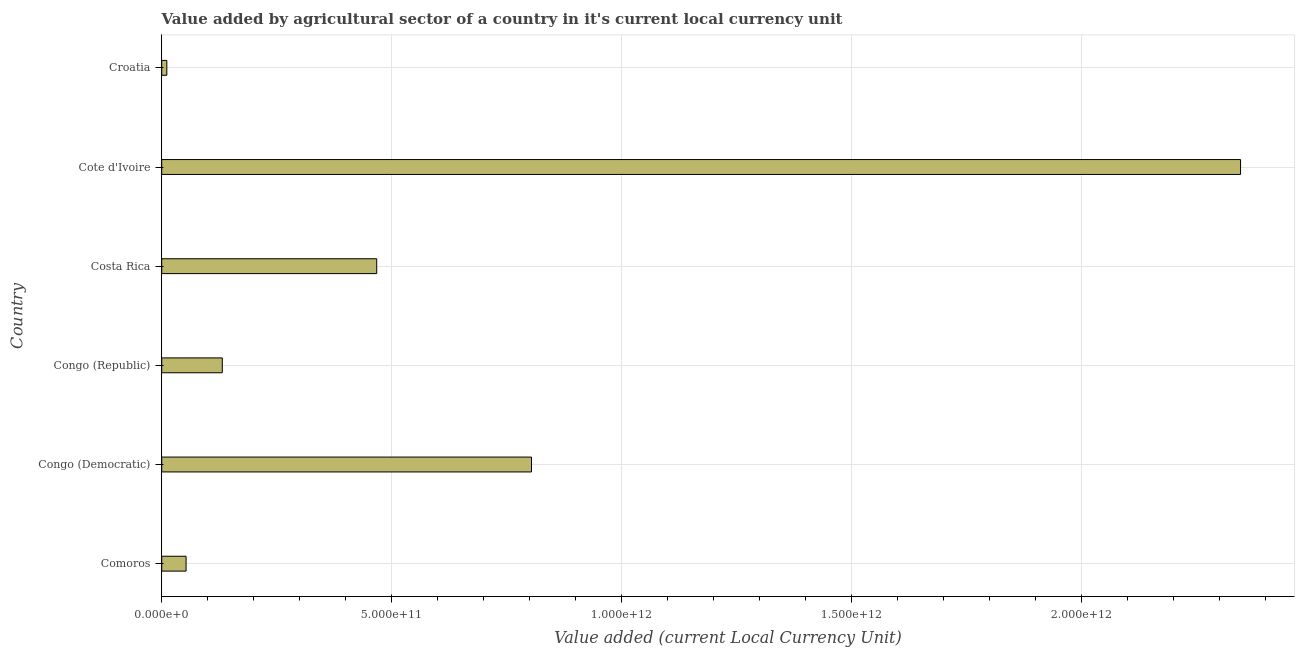Does the graph contain any zero values?
Give a very brief answer. No. What is the title of the graph?
Give a very brief answer. Value added by agricultural sector of a country in it's current local currency unit. What is the label or title of the X-axis?
Keep it short and to the point. Value added (current Local Currency Unit). What is the label or title of the Y-axis?
Your response must be concise. Country. What is the value added by agriculture sector in Congo (Democratic)?
Your response must be concise. 8.04e+11. Across all countries, what is the maximum value added by agriculture sector?
Provide a short and direct response. 2.35e+12. Across all countries, what is the minimum value added by agriculture sector?
Give a very brief answer. 1.11e+1. In which country was the value added by agriculture sector maximum?
Ensure brevity in your answer.  Cote d'Ivoire. In which country was the value added by agriculture sector minimum?
Ensure brevity in your answer.  Croatia. What is the sum of the value added by agriculture sector?
Give a very brief answer. 3.81e+12. What is the difference between the value added by agriculture sector in Congo (Democratic) and Cote d'Ivoire?
Give a very brief answer. -1.54e+12. What is the average value added by agriculture sector per country?
Make the answer very short. 6.36e+11. What is the median value added by agriculture sector?
Provide a succinct answer. 3.00e+11. What is the ratio of the value added by agriculture sector in Comoros to that in Costa Rica?
Your response must be concise. 0.11. What is the difference between the highest and the second highest value added by agriculture sector?
Your response must be concise. 1.54e+12. What is the difference between the highest and the lowest value added by agriculture sector?
Keep it short and to the point. 2.34e+12. Are all the bars in the graph horizontal?
Ensure brevity in your answer.  Yes. How many countries are there in the graph?
Give a very brief answer. 6. What is the difference between two consecutive major ticks on the X-axis?
Your answer should be compact. 5.00e+11. What is the Value added (current Local Currency Unit) of Comoros?
Offer a very short reply. 5.30e+1. What is the Value added (current Local Currency Unit) of Congo (Democratic)?
Provide a short and direct response. 8.04e+11. What is the Value added (current Local Currency Unit) in Congo (Republic)?
Offer a terse response. 1.32e+11. What is the Value added (current Local Currency Unit) of Costa Rica?
Provide a short and direct response. 4.68e+11. What is the Value added (current Local Currency Unit) in Cote d'Ivoire?
Your answer should be very brief. 2.35e+12. What is the Value added (current Local Currency Unit) of Croatia?
Your response must be concise. 1.11e+1. What is the difference between the Value added (current Local Currency Unit) in Comoros and Congo (Democratic)?
Your response must be concise. -7.51e+11. What is the difference between the Value added (current Local Currency Unit) in Comoros and Congo (Republic)?
Offer a very short reply. -7.88e+1. What is the difference between the Value added (current Local Currency Unit) in Comoros and Costa Rica?
Keep it short and to the point. -4.15e+11. What is the difference between the Value added (current Local Currency Unit) in Comoros and Cote d'Ivoire?
Provide a short and direct response. -2.29e+12. What is the difference between the Value added (current Local Currency Unit) in Comoros and Croatia?
Ensure brevity in your answer.  4.19e+1. What is the difference between the Value added (current Local Currency Unit) in Congo (Democratic) and Congo (Republic)?
Offer a terse response. 6.73e+11. What is the difference between the Value added (current Local Currency Unit) in Congo (Democratic) and Costa Rica?
Provide a succinct answer. 3.37e+11. What is the difference between the Value added (current Local Currency Unit) in Congo (Democratic) and Cote d'Ivoire?
Give a very brief answer. -1.54e+12. What is the difference between the Value added (current Local Currency Unit) in Congo (Democratic) and Croatia?
Your answer should be compact. 7.93e+11. What is the difference between the Value added (current Local Currency Unit) in Congo (Republic) and Costa Rica?
Make the answer very short. -3.36e+11. What is the difference between the Value added (current Local Currency Unit) in Congo (Republic) and Cote d'Ivoire?
Your answer should be compact. -2.21e+12. What is the difference between the Value added (current Local Currency Unit) in Congo (Republic) and Croatia?
Your answer should be compact. 1.21e+11. What is the difference between the Value added (current Local Currency Unit) in Costa Rica and Cote d'Ivoire?
Give a very brief answer. -1.88e+12. What is the difference between the Value added (current Local Currency Unit) in Costa Rica and Croatia?
Give a very brief answer. 4.57e+11. What is the difference between the Value added (current Local Currency Unit) in Cote d'Ivoire and Croatia?
Your response must be concise. 2.34e+12. What is the ratio of the Value added (current Local Currency Unit) in Comoros to that in Congo (Democratic)?
Offer a very short reply. 0.07. What is the ratio of the Value added (current Local Currency Unit) in Comoros to that in Congo (Republic)?
Offer a terse response. 0.4. What is the ratio of the Value added (current Local Currency Unit) in Comoros to that in Costa Rica?
Your response must be concise. 0.11. What is the ratio of the Value added (current Local Currency Unit) in Comoros to that in Cote d'Ivoire?
Provide a succinct answer. 0.02. What is the ratio of the Value added (current Local Currency Unit) in Comoros to that in Croatia?
Provide a short and direct response. 4.76. What is the ratio of the Value added (current Local Currency Unit) in Congo (Democratic) to that in Congo (Republic)?
Ensure brevity in your answer.  6.1. What is the ratio of the Value added (current Local Currency Unit) in Congo (Democratic) to that in Costa Rica?
Offer a terse response. 1.72. What is the ratio of the Value added (current Local Currency Unit) in Congo (Democratic) to that in Cote d'Ivoire?
Make the answer very short. 0.34. What is the ratio of the Value added (current Local Currency Unit) in Congo (Democratic) to that in Croatia?
Ensure brevity in your answer.  72.32. What is the ratio of the Value added (current Local Currency Unit) in Congo (Republic) to that in Costa Rica?
Provide a short and direct response. 0.28. What is the ratio of the Value added (current Local Currency Unit) in Congo (Republic) to that in Cote d'Ivoire?
Your response must be concise. 0.06. What is the ratio of the Value added (current Local Currency Unit) in Congo (Republic) to that in Croatia?
Keep it short and to the point. 11.85. What is the ratio of the Value added (current Local Currency Unit) in Costa Rica to that in Cote d'Ivoire?
Provide a short and direct response. 0.2. What is the ratio of the Value added (current Local Currency Unit) in Costa Rica to that in Croatia?
Your answer should be very brief. 42.05. What is the ratio of the Value added (current Local Currency Unit) in Cote d'Ivoire to that in Croatia?
Keep it short and to the point. 210.99. 